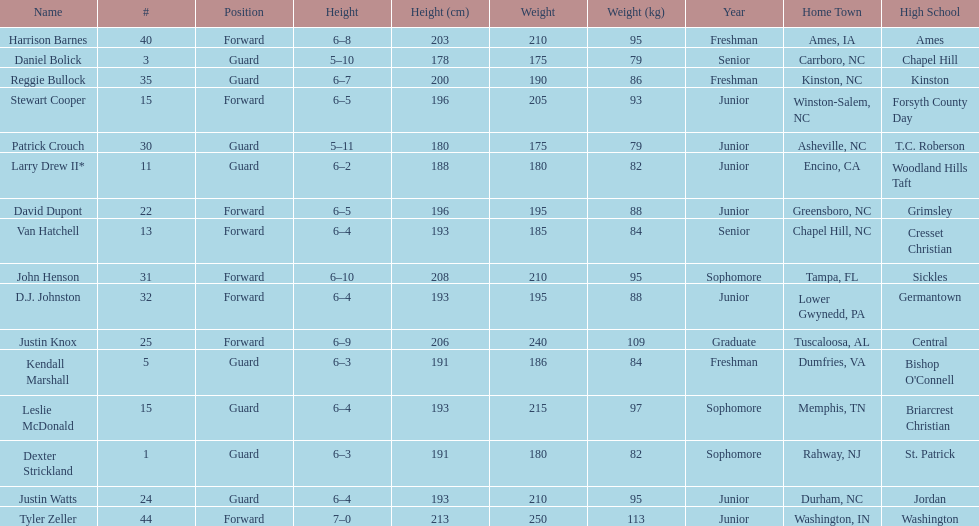Can you give me this table as a dict? {'header': ['Name', '#', 'Position', 'Height', 'Height (cm)', 'Weight', 'Weight (kg)', 'Year', 'Home Town', 'High School'], 'rows': [['Harrison Barnes', '40', 'Forward', '6–8', '203', '210', '95', 'Freshman', 'Ames, IA', 'Ames'], ['Daniel Bolick', '3', 'Guard', '5–10', '178', '175', '79', 'Senior', 'Carrboro, NC', 'Chapel Hill'], ['Reggie Bullock', '35', 'Guard', '6–7', '200', '190', '86', 'Freshman', 'Kinston, NC', 'Kinston'], ['Stewart Cooper', '15', 'Forward', '6–5', '196', '205', '93', 'Junior', 'Winston-Salem, NC', 'Forsyth County Day'], ['Patrick Crouch', '30', 'Guard', '5–11', '180', '175', '79', 'Junior', 'Asheville, NC', 'T.C. Roberson'], ['Larry Drew II*', '11', 'Guard', '6–2', '188', '180', '82', 'Junior', 'Encino, CA', 'Woodland Hills Taft'], ['David Dupont', '22', 'Forward', '6–5', '196', '195', '88', 'Junior', 'Greensboro, NC', 'Grimsley'], ['Van Hatchell', '13', 'Forward', '6–4', '193', '185', '84', 'Senior', 'Chapel Hill, NC', 'Cresset Christian'], ['John Henson', '31', 'Forward', '6–10', '208', '210', '95', 'Sophomore', 'Tampa, FL', 'Sickles'], ['D.J. Johnston', '32', 'Forward', '6–4', '193', '195', '88', 'Junior', 'Lower Gwynedd, PA', 'Germantown'], ['Justin Knox', '25', 'Forward', '6–9', '206', '240', '109', 'Graduate', 'Tuscaloosa, AL', 'Central'], ['Kendall Marshall', '5', 'Guard', '6–3', '191', '186', '84', 'Freshman', 'Dumfries, VA', "Bishop O'Connell"], ['Leslie McDonald', '15', 'Guard', '6–4', '193', '215', '97', 'Sophomore', 'Memphis, TN', 'Briarcrest Christian'], ['Dexter Strickland', '1', 'Guard', '6–3', '191', '180', '82', 'Sophomore', 'Rahway, NJ', 'St. Patrick'], ['Justin Watts', '24', 'Guard', '6–4', '193', '210', '95', 'Junior', 'Durham, NC', 'Jordan'], ['Tyler Zeller', '44', 'Forward', '7–0', '213', '250', '113', 'Junior', 'Washington, IN', 'Washington']]} How many players play a position other than guard? 8. 